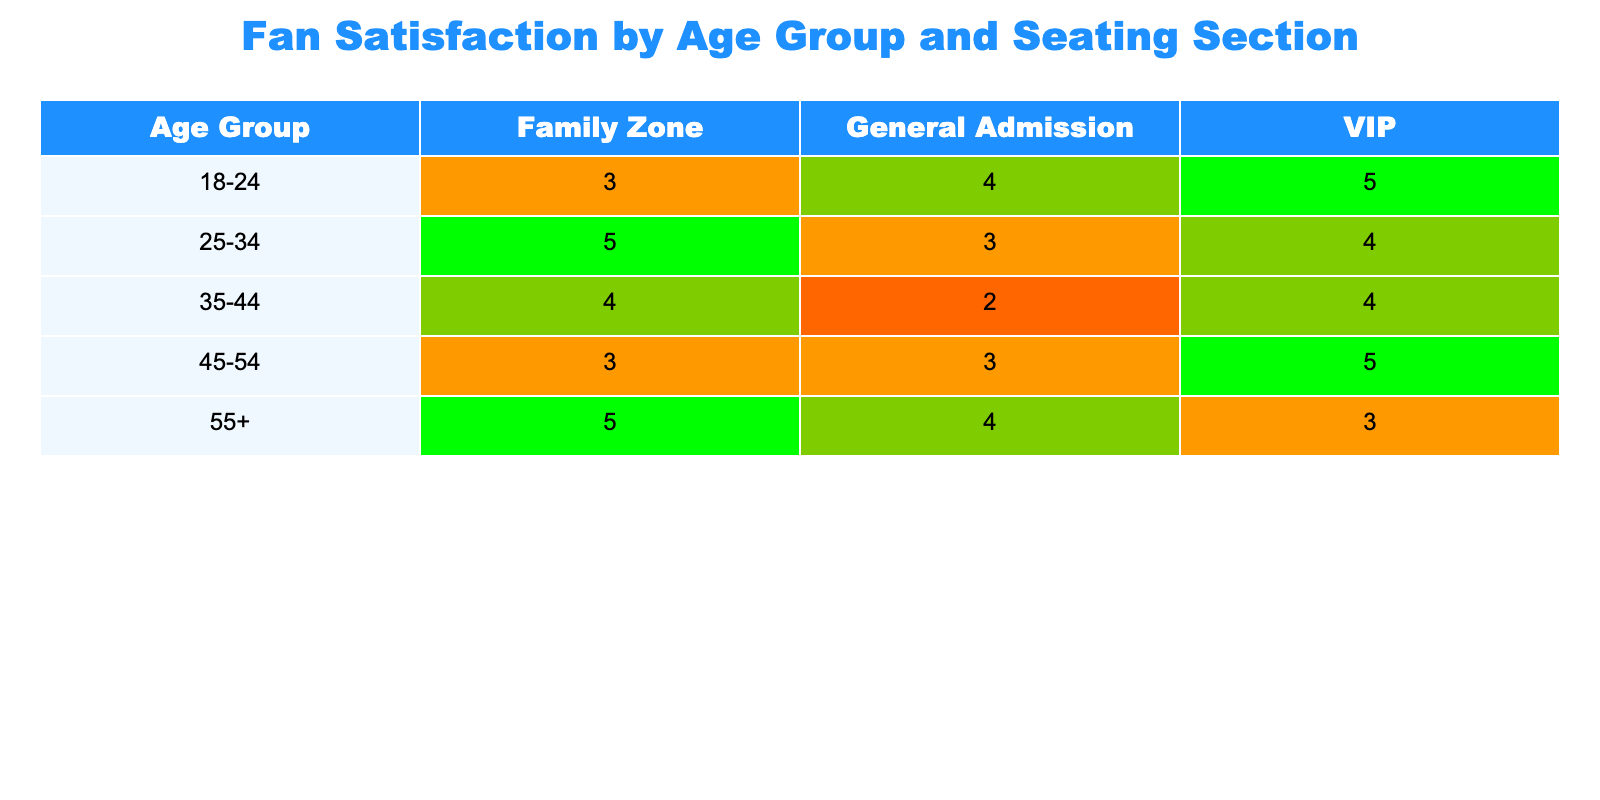What is the satisfaction rating for the VIP section in the 45-54 age group? The table indicates the satisfaction rating for each seating section under different age groups. Looking under the VIP column for the 45-54 age group, the rating is 5.
Answer: 5 Which age group has the highest average satisfaction rating in the Family Zone? To find the average for the Family Zone, we look at the ratings for each age group: 3 (18-24) + 5 (25-34) + 4 (35-44) + 3 (45-54) + 5 (55+). This gives us a total of 20, and there are 5 age groups, so the average is 20/5 = 4.
Answer: 4 Is the average satisfaction rating for the General Admission section higher than that for the VIP section across all age groups? We calculate the average for General Admission: (4 + 3 + 2 + 3 + 4) = 16, with 5 ratings leading to an average of 16/5 = 3.2. For VIP: (5 + 4 + 4 + 5 + 3) = 21, with 5 ratings giving an average of 21/5 = 4.2. Since 3.2 is less than 4.2, the statement is false.
Answer: No What is the total satisfaction rating for the 25-34 age group across all seating sections? To get the total for the 25-34 age group, we add the ratings for each section: 3 (General Admission) + 4 (VIP) + 5 (Family Zone) = 12.
Answer: 12 Do fans aged 55 and over prefer the General Admission section based on their satisfaction ratings? The satisfaction rating for 55+ in General Admission is 4, but we also check the ratings for other seating: VIP is 3 and Family Zone is 5. Since the Family Zone has a higher rating, they do not prefer General Admission based on satisfaction.
Answer: No Which seating section received the lowest satisfaction rating from fans aged 35-44? Looking at the 35-44 age group, the satisfaction ratings are: 2 (General Admission), 4 (VIP), and 4 (Family Zone). The lowest rating is clearly 2 for the General Admission section.
Answer: General Admission What is the satisfaction rating difference between the Family Zone and VIP for the 18-24 age group? The satisfaction rating for the Family Zone is 3, while for the VIP it is 5. The difference is calculated as 5 (VIP) - 3 (Family Zone) = 2.
Answer: 2 Which seating section has the overall highest satisfaction rating in the table? We look across all age groups for each section: General Admission has an average of 3.2, VIP has an average of 4.2, and Family Zone has an average of 4. The highest average is 4 for the Family Zone.
Answer: Family Zone 